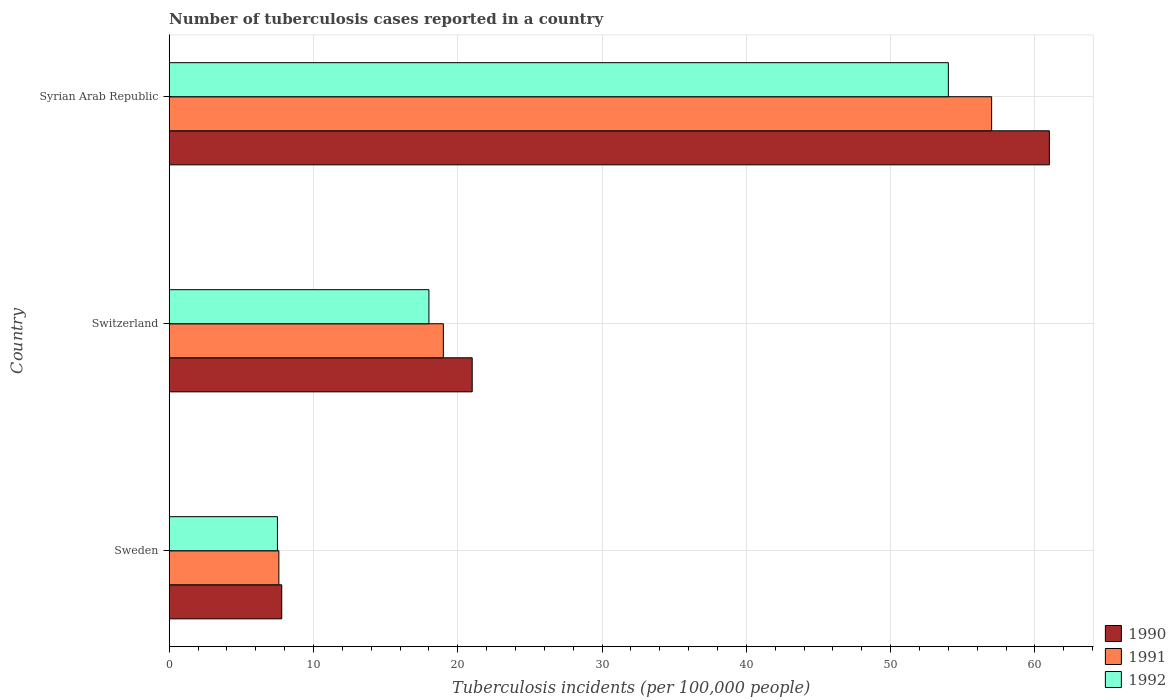How many groups of bars are there?
Your answer should be very brief. 3. Are the number of bars on each tick of the Y-axis equal?
Ensure brevity in your answer.  Yes. What is the label of the 1st group of bars from the top?
Offer a terse response. Syrian Arab Republic. What is the number of tuberculosis cases reported in in 1990 in Syrian Arab Republic?
Ensure brevity in your answer.  61. Across all countries, what is the maximum number of tuberculosis cases reported in in 1991?
Ensure brevity in your answer.  57. In which country was the number of tuberculosis cases reported in in 1992 maximum?
Provide a short and direct response. Syrian Arab Republic. What is the total number of tuberculosis cases reported in in 1992 in the graph?
Offer a very short reply. 79.5. What is the difference between the number of tuberculosis cases reported in in 1991 in Sweden and that in Switzerland?
Keep it short and to the point. -11.4. What is the average number of tuberculosis cases reported in in 1992 per country?
Your response must be concise. 26.5. In how many countries, is the number of tuberculosis cases reported in in 1990 greater than 12 ?
Offer a very short reply. 2. What is the ratio of the number of tuberculosis cases reported in in 1990 in Sweden to that in Switzerland?
Make the answer very short. 0.37. Is the number of tuberculosis cases reported in in 1991 in Switzerland less than that in Syrian Arab Republic?
Keep it short and to the point. Yes. What is the difference between the highest and the second highest number of tuberculosis cases reported in in 1991?
Your answer should be compact. 38. What is the difference between the highest and the lowest number of tuberculosis cases reported in in 1992?
Provide a short and direct response. 46.5. What does the 3rd bar from the top in Switzerland represents?
Offer a very short reply. 1990. What does the 3rd bar from the bottom in Switzerland represents?
Your response must be concise. 1992. Are all the bars in the graph horizontal?
Give a very brief answer. Yes. How many countries are there in the graph?
Keep it short and to the point. 3. What is the difference between two consecutive major ticks on the X-axis?
Keep it short and to the point. 10. Where does the legend appear in the graph?
Your answer should be very brief. Bottom right. How many legend labels are there?
Offer a very short reply. 3. How are the legend labels stacked?
Your answer should be very brief. Vertical. What is the title of the graph?
Provide a short and direct response. Number of tuberculosis cases reported in a country. What is the label or title of the X-axis?
Offer a very short reply. Tuberculosis incidents (per 100,0 people). What is the label or title of the Y-axis?
Offer a very short reply. Country. What is the Tuberculosis incidents (per 100,000 people) in 1990 in Sweden?
Your answer should be compact. 7.8. What is the Tuberculosis incidents (per 100,000 people) of 1991 in Sweden?
Offer a terse response. 7.6. What is the Tuberculosis incidents (per 100,000 people) in 1990 in Switzerland?
Give a very brief answer. 21. What is the Tuberculosis incidents (per 100,000 people) of 1992 in Switzerland?
Keep it short and to the point. 18. What is the Tuberculosis incidents (per 100,000 people) of 1990 in Syrian Arab Republic?
Make the answer very short. 61. What is the Tuberculosis incidents (per 100,000 people) of 1992 in Syrian Arab Republic?
Your answer should be compact. 54. Across all countries, what is the maximum Tuberculosis incidents (per 100,000 people) in 1990?
Your response must be concise. 61. Across all countries, what is the maximum Tuberculosis incidents (per 100,000 people) in 1991?
Provide a short and direct response. 57. Across all countries, what is the minimum Tuberculosis incidents (per 100,000 people) in 1991?
Keep it short and to the point. 7.6. Across all countries, what is the minimum Tuberculosis incidents (per 100,000 people) of 1992?
Give a very brief answer. 7.5. What is the total Tuberculosis incidents (per 100,000 people) of 1990 in the graph?
Provide a succinct answer. 89.8. What is the total Tuberculosis incidents (per 100,000 people) in 1991 in the graph?
Offer a very short reply. 83.6. What is the total Tuberculosis incidents (per 100,000 people) in 1992 in the graph?
Ensure brevity in your answer.  79.5. What is the difference between the Tuberculosis incidents (per 100,000 people) of 1990 in Sweden and that in Syrian Arab Republic?
Provide a short and direct response. -53.2. What is the difference between the Tuberculosis incidents (per 100,000 people) in 1991 in Sweden and that in Syrian Arab Republic?
Offer a very short reply. -49.4. What is the difference between the Tuberculosis incidents (per 100,000 people) of 1992 in Sweden and that in Syrian Arab Republic?
Ensure brevity in your answer.  -46.5. What is the difference between the Tuberculosis incidents (per 100,000 people) in 1991 in Switzerland and that in Syrian Arab Republic?
Give a very brief answer. -38. What is the difference between the Tuberculosis incidents (per 100,000 people) in 1992 in Switzerland and that in Syrian Arab Republic?
Provide a short and direct response. -36. What is the difference between the Tuberculosis incidents (per 100,000 people) of 1990 in Sweden and the Tuberculosis incidents (per 100,000 people) of 1991 in Switzerland?
Ensure brevity in your answer.  -11.2. What is the difference between the Tuberculosis incidents (per 100,000 people) of 1990 in Sweden and the Tuberculosis incidents (per 100,000 people) of 1992 in Switzerland?
Ensure brevity in your answer.  -10.2. What is the difference between the Tuberculosis incidents (per 100,000 people) in 1991 in Sweden and the Tuberculosis incidents (per 100,000 people) in 1992 in Switzerland?
Make the answer very short. -10.4. What is the difference between the Tuberculosis incidents (per 100,000 people) of 1990 in Sweden and the Tuberculosis incidents (per 100,000 people) of 1991 in Syrian Arab Republic?
Provide a succinct answer. -49.2. What is the difference between the Tuberculosis incidents (per 100,000 people) of 1990 in Sweden and the Tuberculosis incidents (per 100,000 people) of 1992 in Syrian Arab Republic?
Your answer should be very brief. -46.2. What is the difference between the Tuberculosis incidents (per 100,000 people) of 1991 in Sweden and the Tuberculosis incidents (per 100,000 people) of 1992 in Syrian Arab Republic?
Offer a very short reply. -46.4. What is the difference between the Tuberculosis incidents (per 100,000 people) of 1990 in Switzerland and the Tuberculosis incidents (per 100,000 people) of 1991 in Syrian Arab Republic?
Provide a short and direct response. -36. What is the difference between the Tuberculosis incidents (per 100,000 people) of 1990 in Switzerland and the Tuberculosis incidents (per 100,000 people) of 1992 in Syrian Arab Republic?
Keep it short and to the point. -33. What is the difference between the Tuberculosis incidents (per 100,000 people) of 1991 in Switzerland and the Tuberculosis incidents (per 100,000 people) of 1992 in Syrian Arab Republic?
Your answer should be compact. -35. What is the average Tuberculosis incidents (per 100,000 people) in 1990 per country?
Your answer should be very brief. 29.93. What is the average Tuberculosis incidents (per 100,000 people) in 1991 per country?
Ensure brevity in your answer.  27.87. What is the average Tuberculosis incidents (per 100,000 people) in 1992 per country?
Keep it short and to the point. 26.5. What is the difference between the Tuberculosis incidents (per 100,000 people) of 1990 and Tuberculosis incidents (per 100,000 people) of 1992 in Sweden?
Your response must be concise. 0.3. What is the difference between the Tuberculosis incidents (per 100,000 people) in 1991 and Tuberculosis incidents (per 100,000 people) in 1992 in Sweden?
Your answer should be compact. 0.1. What is the difference between the Tuberculosis incidents (per 100,000 people) of 1990 and Tuberculosis incidents (per 100,000 people) of 1991 in Switzerland?
Your answer should be very brief. 2. What is the difference between the Tuberculosis incidents (per 100,000 people) in 1990 and Tuberculosis incidents (per 100,000 people) in 1991 in Syrian Arab Republic?
Offer a terse response. 4. What is the ratio of the Tuberculosis incidents (per 100,000 people) of 1990 in Sweden to that in Switzerland?
Provide a succinct answer. 0.37. What is the ratio of the Tuberculosis incidents (per 100,000 people) in 1992 in Sweden to that in Switzerland?
Provide a succinct answer. 0.42. What is the ratio of the Tuberculosis incidents (per 100,000 people) in 1990 in Sweden to that in Syrian Arab Republic?
Your answer should be compact. 0.13. What is the ratio of the Tuberculosis incidents (per 100,000 people) of 1991 in Sweden to that in Syrian Arab Republic?
Your answer should be compact. 0.13. What is the ratio of the Tuberculosis incidents (per 100,000 people) of 1992 in Sweden to that in Syrian Arab Republic?
Ensure brevity in your answer.  0.14. What is the ratio of the Tuberculosis incidents (per 100,000 people) of 1990 in Switzerland to that in Syrian Arab Republic?
Your response must be concise. 0.34. What is the ratio of the Tuberculosis incidents (per 100,000 people) of 1991 in Switzerland to that in Syrian Arab Republic?
Make the answer very short. 0.33. What is the ratio of the Tuberculosis incidents (per 100,000 people) in 1992 in Switzerland to that in Syrian Arab Republic?
Offer a terse response. 0.33. What is the difference between the highest and the second highest Tuberculosis incidents (per 100,000 people) of 1990?
Make the answer very short. 40. What is the difference between the highest and the lowest Tuberculosis incidents (per 100,000 people) in 1990?
Your answer should be compact. 53.2. What is the difference between the highest and the lowest Tuberculosis incidents (per 100,000 people) in 1991?
Ensure brevity in your answer.  49.4. What is the difference between the highest and the lowest Tuberculosis incidents (per 100,000 people) of 1992?
Your response must be concise. 46.5. 